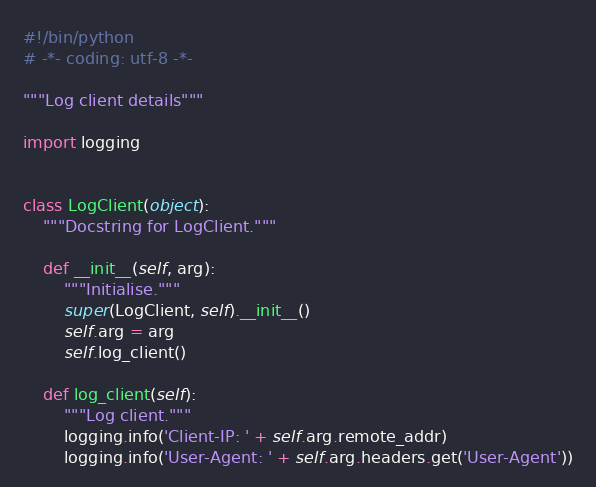Convert code to text. <code><loc_0><loc_0><loc_500><loc_500><_Python_>#!/bin/python
# -*- coding: utf-8 -*-

"""Log client details"""

import logging


class LogClient(object):
    """Docstring for LogClient."""

    def __init__(self, arg):
        """Initialise."""
        super(LogClient, self).__init__()
        self.arg = arg
        self.log_client()

    def log_client(self):
        """Log client."""
        logging.info('Client-IP: ' + self.arg.remote_addr)
        logging.info('User-Agent: ' + self.arg.headers.get('User-Agent'))
</code> 